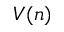Convert formula to latex. <formula><loc_0><loc_0><loc_500><loc_500>V ( n )</formula> 